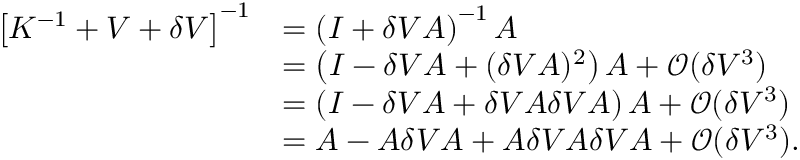Convert formula to latex. <formula><loc_0><loc_0><loc_500><loc_500>\begin{array} { r l } { \left [ K ^ { - 1 } + V + \delta V \right ] ^ { - 1 } } & { = \left ( I + \delta V A \right ) ^ { - 1 } A } \\ & { = \left ( I - \delta V A + ( \delta V A ) ^ { 2 } \right ) A + \mathcal { O } ( \delta V ^ { 3 } ) } \\ & { = \left ( I - \delta V A + \delta V A \delta V A \right ) A + \mathcal { O } ( \delta V ^ { 3 } ) } \\ & { = A - A \delta V A + A \delta V A \delta V A + \mathcal { O } ( \delta V ^ { 3 } ) . } \end{array}</formula> 